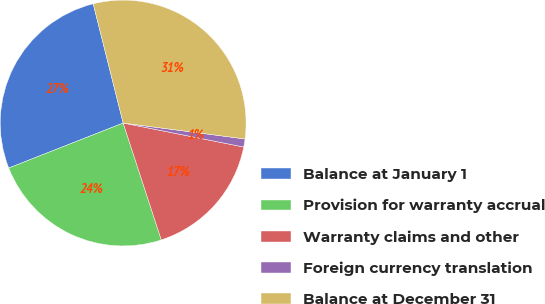<chart> <loc_0><loc_0><loc_500><loc_500><pie_chart><fcel>Balance at January 1<fcel>Provision for warranty accrual<fcel>Warranty claims and other<fcel>Foreign currency translation<fcel>Balance at December 31<nl><fcel>27.05%<fcel>24.06%<fcel>16.85%<fcel>1.06%<fcel>30.99%<nl></chart> 